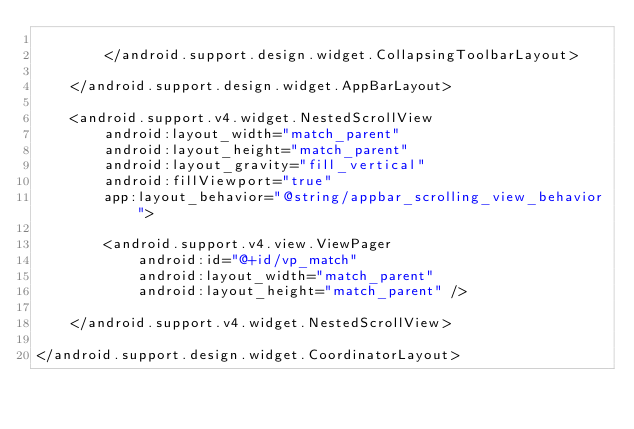<code> <loc_0><loc_0><loc_500><loc_500><_XML_>
        </android.support.design.widget.CollapsingToolbarLayout>

    </android.support.design.widget.AppBarLayout>

    <android.support.v4.widget.NestedScrollView
        android:layout_width="match_parent"
        android:layout_height="match_parent"
        android:layout_gravity="fill_vertical"
        android:fillViewport="true"
        app:layout_behavior="@string/appbar_scrolling_view_behavior">

        <android.support.v4.view.ViewPager
            android:id="@+id/vp_match"
            android:layout_width="match_parent"
            android:layout_height="match_parent" />

    </android.support.v4.widget.NestedScrollView>

</android.support.design.widget.CoordinatorLayout></code> 